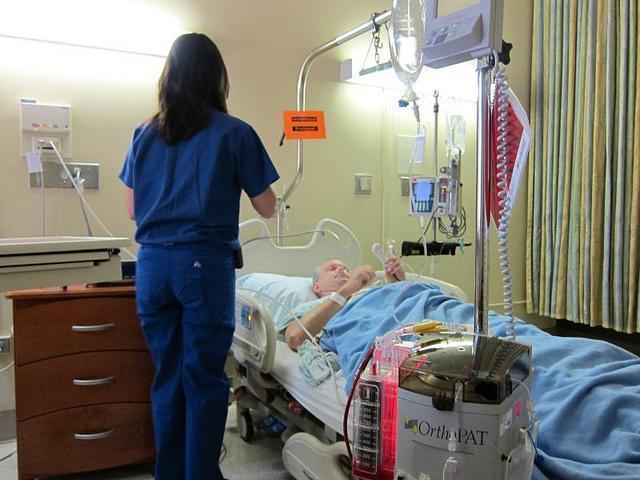How many people are in the picture?
Give a very brief answer. 2. 